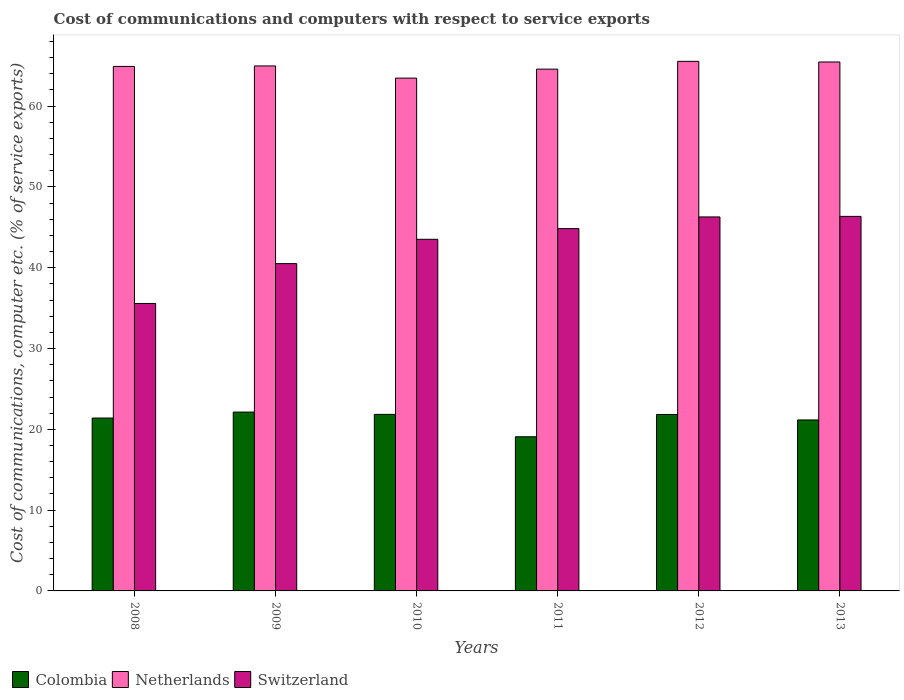How many different coloured bars are there?
Your answer should be very brief. 3. Are the number of bars per tick equal to the number of legend labels?
Your answer should be compact. Yes. Are the number of bars on each tick of the X-axis equal?
Provide a succinct answer. Yes. How many bars are there on the 1st tick from the left?
Your answer should be compact. 3. How many bars are there on the 5th tick from the right?
Keep it short and to the point. 3. What is the label of the 3rd group of bars from the left?
Your response must be concise. 2010. What is the cost of communications and computers in Colombia in 2008?
Ensure brevity in your answer.  21.4. Across all years, what is the maximum cost of communications and computers in Switzerland?
Give a very brief answer. 46.35. Across all years, what is the minimum cost of communications and computers in Switzerland?
Ensure brevity in your answer.  35.58. What is the total cost of communications and computers in Switzerland in the graph?
Your answer should be very brief. 257.08. What is the difference between the cost of communications and computers in Switzerland in 2008 and that in 2012?
Your answer should be very brief. -10.71. What is the difference between the cost of communications and computers in Switzerland in 2009 and the cost of communications and computers in Netherlands in 2013?
Your answer should be compact. -24.96. What is the average cost of communications and computers in Switzerland per year?
Your answer should be very brief. 42.85. In the year 2011, what is the difference between the cost of communications and computers in Switzerland and cost of communications and computers in Colombia?
Keep it short and to the point. 25.76. In how many years, is the cost of communications and computers in Netherlands greater than 54 %?
Provide a short and direct response. 6. What is the ratio of the cost of communications and computers in Netherlands in 2009 to that in 2013?
Make the answer very short. 0.99. What is the difference between the highest and the second highest cost of communications and computers in Switzerland?
Offer a terse response. 0.07. What is the difference between the highest and the lowest cost of communications and computers in Colombia?
Make the answer very short. 3.06. What does the 3rd bar from the left in 2012 represents?
Your answer should be very brief. Switzerland. Is it the case that in every year, the sum of the cost of communications and computers in Switzerland and cost of communications and computers in Colombia is greater than the cost of communications and computers in Netherlands?
Provide a succinct answer. No. Are all the bars in the graph horizontal?
Your answer should be compact. No. Are the values on the major ticks of Y-axis written in scientific E-notation?
Your answer should be very brief. No. Where does the legend appear in the graph?
Keep it short and to the point. Bottom left. How are the legend labels stacked?
Offer a very short reply. Horizontal. What is the title of the graph?
Provide a succinct answer. Cost of communications and computers with respect to service exports. What is the label or title of the Y-axis?
Your answer should be compact. Cost of communications, computer etc. (% of service exports). What is the Cost of communications, computer etc. (% of service exports) in Colombia in 2008?
Offer a very short reply. 21.4. What is the Cost of communications, computer etc. (% of service exports) of Netherlands in 2008?
Provide a succinct answer. 64.91. What is the Cost of communications, computer etc. (% of service exports) of Switzerland in 2008?
Offer a very short reply. 35.58. What is the Cost of communications, computer etc. (% of service exports) of Colombia in 2009?
Your answer should be very brief. 22.14. What is the Cost of communications, computer etc. (% of service exports) of Netherlands in 2009?
Offer a terse response. 64.97. What is the Cost of communications, computer etc. (% of service exports) in Switzerland in 2009?
Provide a succinct answer. 40.51. What is the Cost of communications, computer etc. (% of service exports) in Colombia in 2010?
Keep it short and to the point. 21.85. What is the Cost of communications, computer etc. (% of service exports) in Netherlands in 2010?
Your answer should be compact. 63.47. What is the Cost of communications, computer etc. (% of service exports) in Switzerland in 2010?
Your answer should be compact. 43.52. What is the Cost of communications, computer etc. (% of service exports) of Colombia in 2011?
Provide a short and direct response. 19.08. What is the Cost of communications, computer etc. (% of service exports) in Netherlands in 2011?
Keep it short and to the point. 64.58. What is the Cost of communications, computer etc. (% of service exports) in Switzerland in 2011?
Your answer should be very brief. 44.84. What is the Cost of communications, computer etc. (% of service exports) in Colombia in 2012?
Make the answer very short. 21.84. What is the Cost of communications, computer etc. (% of service exports) in Netherlands in 2012?
Ensure brevity in your answer.  65.54. What is the Cost of communications, computer etc. (% of service exports) of Switzerland in 2012?
Your answer should be very brief. 46.29. What is the Cost of communications, computer etc. (% of service exports) of Colombia in 2013?
Make the answer very short. 21.16. What is the Cost of communications, computer etc. (% of service exports) in Netherlands in 2013?
Keep it short and to the point. 65.46. What is the Cost of communications, computer etc. (% of service exports) of Switzerland in 2013?
Your answer should be compact. 46.35. Across all years, what is the maximum Cost of communications, computer etc. (% of service exports) of Colombia?
Offer a terse response. 22.14. Across all years, what is the maximum Cost of communications, computer etc. (% of service exports) of Netherlands?
Your answer should be compact. 65.54. Across all years, what is the maximum Cost of communications, computer etc. (% of service exports) in Switzerland?
Your response must be concise. 46.35. Across all years, what is the minimum Cost of communications, computer etc. (% of service exports) in Colombia?
Give a very brief answer. 19.08. Across all years, what is the minimum Cost of communications, computer etc. (% of service exports) in Netherlands?
Offer a terse response. 63.47. Across all years, what is the minimum Cost of communications, computer etc. (% of service exports) of Switzerland?
Ensure brevity in your answer.  35.58. What is the total Cost of communications, computer etc. (% of service exports) of Colombia in the graph?
Your answer should be compact. 127.46. What is the total Cost of communications, computer etc. (% of service exports) of Netherlands in the graph?
Offer a terse response. 388.93. What is the total Cost of communications, computer etc. (% of service exports) in Switzerland in the graph?
Your response must be concise. 257.08. What is the difference between the Cost of communications, computer etc. (% of service exports) in Colombia in 2008 and that in 2009?
Keep it short and to the point. -0.74. What is the difference between the Cost of communications, computer etc. (% of service exports) of Netherlands in 2008 and that in 2009?
Provide a succinct answer. -0.06. What is the difference between the Cost of communications, computer etc. (% of service exports) in Switzerland in 2008 and that in 2009?
Ensure brevity in your answer.  -4.93. What is the difference between the Cost of communications, computer etc. (% of service exports) in Colombia in 2008 and that in 2010?
Offer a terse response. -0.45. What is the difference between the Cost of communications, computer etc. (% of service exports) in Netherlands in 2008 and that in 2010?
Make the answer very short. 1.45. What is the difference between the Cost of communications, computer etc. (% of service exports) of Switzerland in 2008 and that in 2010?
Your response must be concise. -7.94. What is the difference between the Cost of communications, computer etc. (% of service exports) of Colombia in 2008 and that in 2011?
Give a very brief answer. 2.32. What is the difference between the Cost of communications, computer etc. (% of service exports) in Netherlands in 2008 and that in 2011?
Provide a succinct answer. 0.34. What is the difference between the Cost of communications, computer etc. (% of service exports) of Switzerland in 2008 and that in 2011?
Your response must be concise. -9.26. What is the difference between the Cost of communications, computer etc. (% of service exports) of Colombia in 2008 and that in 2012?
Your response must be concise. -0.44. What is the difference between the Cost of communications, computer etc. (% of service exports) in Netherlands in 2008 and that in 2012?
Offer a very short reply. -0.63. What is the difference between the Cost of communications, computer etc. (% of service exports) of Switzerland in 2008 and that in 2012?
Provide a succinct answer. -10.71. What is the difference between the Cost of communications, computer etc. (% of service exports) of Colombia in 2008 and that in 2013?
Ensure brevity in your answer.  0.24. What is the difference between the Cost of communications, computer etc. (% of service exports) of Netherlands in 2008 and that in 2013?
Provide a succinct answer. -0.55. What is the difference between the Cost of communications, computer etc. (% of service exports) in Switzerland in 2008 and that in 2013?
Make the answer very short. -10.78. What is the difference between the Cost of communications, computer etc. (% of service exports) of Colombia in 2009 and that in 2010?
Give a very brief answer. 0.29. What is the difference between the Cost of communications, computer etc. (% of service exports) of Netherlands in 2009 and that in 2010?
Your answer should be very brief. 1.51. What is the difference between the Cost of communications, computer etc. (% of service exports) in Switzerland in 2009 and that in 2010?
Your response must be concise. -3.01. What is the difference between the Cost of communications, computer etc. (% of service exports) of Colombia in 2009 and that in 2011?
Offer a terse response. 3.06. What is the difference between the Cost of communications, computer etc. (% of service exports) of Netherlands in 2009 and that in 2011?
Ensure brevity in your answer.  0.4. What is the difference between the Cost of communications, computer etc. (% of service exports) in Switzerland in 2009 and that in 2011?
Offer a very short reply. -4.33. What is the difference between the Cost of communications, computer etc. (% of service exports) of Colombia in 2009 and that in 2012?
Give a very brief answer. 0.3. What is the difference between the Cost of communications, computer etc. (% of service exports) of Netherlands in 2009 and that in 2012?
Offer a very short reply. -0.57. What is the difference between the Cost of communications, computer etc. (% of service exports) in Switzerland in 2009 and that in 2012?
Provide a short and direct response. -5.78. What is the difference between the Cost of communications, computer etc. (% of service exports) of Colombia in 2009 and that in 2013?
Make the answer very short. 0.98. What is the difference between the Cost of communications, computer etc. (% of service exports) of Netherlands in 2009 and that in 2013?
Offer a very short reply. -0.49. What is the difference between the Cost of communications, computer etc. (% of service exports) of Switzerland in 2009 and that in 2013?
Offer a very short reply. -5.85. What is the difference between the Cost of communications, computer etc. (% of service exports) in Colombia in 2010 and that in 2011?
Provide a short and direct response. 2.77. What is the difference between the Cost of communications, computer etc. (% of service exports) of Netherlands in 2010 and that in 2011?
Offer a very short reply. -1.11. What is the difference between the Cost of communications, computer etc. (% of service exports) in Switzerland in 2010 and that in 2011?
Provide a succinct answer. -1.32. What is the difference between the Cost of communications, computer etc. (% of service exports) in Colombia in 2010 and that in 2012?
Your answer should be compact. 0.01. What is the difference between the Cost of communications, computer etc. (% of service exports) of Netherlands in 2010 and that in 2012?
Make the answer very short. -2.07. What is the difference between the Cost of communications, computer etc. (% of service exports) in Switzerland in 2010 and that in 2012?
Your answer should be compact. -2.77. What is the difference between the Cost of communications, computer etc. (% of service exports) of Colombia in 2010 and that in 2013?
Your answer should be very brief. 0.69. What is the difference between the Cost of communications, computer etc. (% of service exports) in Netherlands in 2010 and that in 2013?
Ensure brevity in your answer.  -2. What is the difference between the Cost of communications, computer etc. (% of service exports) of Switzerland in 2010 and that in 2013?
Your answer should be very brief. -2.84. What is the difference between the Cost of communications, computer etc. (% of service exports) of Colombia in 2011 and that in 2012?
Ensure brevity in your answer.  -2.76. What is the difference between the Cost of communications, computer etc. (% of service exports) in Netherlands in 2011 and that in 2012?
Keep it short and to the point. -0.96. What is the difference between the Cost of communications, computer etc. (% of service exports) of Switzerland in 2011 and that in 2012?
Your answer should be compact. -1.45. What is the difference between the Cost of communications, computer etc. (% of service exports) of Colombia in 2011 and that in 2013?
Provide a succinct answer. -2.08. What is the difference between the Cost of communications, computer etc. (% of service exports) of Netherlands in 2011 and that in 2013?
Your answer should be very brief. -0.89. What is the difference between the Cost of communications, computer etc. (% of service exports) of Switzerland in 2011 and that in 2013?
Your answer should be very brief. -1.52. What is the difference between the Cost of communications, computer etc. (% of service exports) in Colombia in 2012 and that in 2013?
Give a very brief answer. 0.68. What is the difference between the Cost of communications, computer etc. (% of service exports) in Netherlands in 2012 and that in 2013?
Make the answer very short. 0.08. What is the difference between the Cost of communications, computer etc. (% of service exports) in Switzerland in 2012 and that in 2013?
Your response must be concise. -0.07. What is the difference between the Cost of communications, computer etc. (% of service exports) of Colombia in 2008 and the Cost of communications, computer etc. (% of service exports) of Netherlands in 2009?
Offer a terse response. -43.58. What is the difference between the Cost of communications, computer etc. (% of service exports) in Colombia in 2008 and the Cost of communications, computer etc. (% of service exports) in Switzerland in 2009?
Your response must be concise. -19.11. What is the difference between the Cost of communications, computer etc. (% of service exports) of Netherlands in 2008 and the Cost of communications, computer etc. (% of service exports) of Switzerland in 2009?
Make the answer very short. 24.4. What is the difference between the Cost of communications, computer etc. (% of service exports) of Colombia in 2008 and the Cost of communications, computer etc. (% of service exports) of Netherlands in 2010?
Provide a short and direct response. -42.07. What is the difference between the Cost of communications, computer etc. (% of service exports) of Colombia in 2008 and the Cost of communications, computer etc. (% of service exports) of Switzerland in 2010?
Offer a very short reply. -22.12. What is the difference between the Cost of communications, computer etc. (% of service exports) of Netherlands in 2008 and the Cost of communications, computer etc. (% of service exports) of Switzerland in 2010?
Offer a very short reply. 21.39. What is the difference between the Cost of communications, computer etc. (% of service exports) of Colombia in 2008 and the Cost of communications, computer etc. (% of service exports) of Netherlands in 2011?
Ensure brevity in your answer.  -43.18. What is the difference between the Cost of communications, computer etc. (% of service exports) in Colombia in 2008 and the Cost of communications, computer etc. (% of service exports) in Switzerland in 2011?
Your answer should be compact. -23.44. What is the difference between the Cost of communications, computer etc. (% of service exports) of Netherlands in 2008 and the Cost of communications, computer etc. (% of service exports) of Switzerland in 2011?
Make the answer very short. 20.07. What is the difference between the Cost of communications, computer etc. (% of service exports) of Colombia in 2008 and the Cost of communications, computer etc. (% of service exports) of Netherlands in 2012?
Keep it short and to the point. -44.15. What is the difference between the Cost of communications, computer etc. (% of service exports) in Colombia in 2008 and the Cost of communications, computer etc. (% of service exports) in Switzerland in 2012?
Offer a very short reply. -24.89. What is the difference between the Cost of communications, computer etc. (% of service exports) in Netherlands in 2008 and the Cost of communications, computer etc. (% of service exports) in Switzerland in 2012?
Provide a succinct answer. 18.63. What is the difference between the Cost of communications, computer etc. (% of service exports) in Colombia in 2008 and the Cost of communications, computer etc. (% of service exports) in Netherlands in 2013?
Ensure brevity in your answer.  -44.07. What is the difference between the Cost of communications, computer etc. (% of service exports) in Colombia in 2008 and the Cost of communications, computer etc. (% of service exports) in Switzerland in 2013?
Ensure brevity in your answer.  -24.96. What is the difference between the Cost of communications, computer etc. (% of service exports) of Netherlands in 2008 and the Cost of communications, computer etc. (% of service exports) of Switzerland in 2013?
Provide a succinct answer. 18.56. What is the difference between the Cost of communications, computer etc. (% of service exports) in Colombia in 2009 and the Cost of communications, computer etc. (% of service exports) in Netherlands in 2010?
Your response must be concise. -41.33. What is the difference between the Cost of communications, computer etc. (% of service exports) of Colombia in 2009 and the Cost of communications, computer etc. (% of service exports) of Switzerland in 2010?
Ensure brevity in your answer.  -21.38. What is the difference between the Cost of communications, computer etc. (% of service exports) of Netherlands in 2009 and the Cost of communications, computer etc. (% of service exports) of Switzerland in 2010?
Ensure brevity in your answer.  21.45. What is the difference between the Cost of communications, computer etc. (% of service exports) in Colombia in 2009 and the Cost of communications, computer etc. (% of service exports) in Netherlands in 2011?
Your response must be concise. -42.44. What is the difference between the Cost of communications, computer etc. (% of service exports) in Colombia in 2009 and the Cost of communications, computer etc. (% of service exports) in Switzerland in 2011?
Offer a terse response. -22.7. What is the difference between the Cost of communications, computer etc. (% of service exports) in Netherlands in 2009 and the Cost of communications, computer etc. (% of service exports) in Switzerland in 2011?
Offer a very short reply. 20.13. What is the difference between the Cost of communications, computer etc. (% of service exports) in Colombia in 2009 and the Cost of communications, computer etc. (% of service exports) in Netherlands in 2012?
Ensure brevity in your answer.  -43.4. What is the difference between the Cost of communications, computer etc. (% of service exports) of Colombia in 2009 and the Cost of communications, computer etc. (% of service exports) of Switzerland in 2012?
Ensure brevity in your answer.  -24.15. What is the difference between the Cost of communications, computer etc. (% of service exports) in Netherlands in 2009 and the Cost of communications, computer etc. (% of service exports) in Switzerland in 2012?
Provide a short and direct response. 18.69. What is the difference between the Cost of communications, computer etc. (% of service exports) of Colombia in 2009 and the Cost of communications, computer etc. (% of service exports) of Netherlands in 2013?
Your answer should be compact. -43.33. What is the difference between the Cost of communications, computer etc. (% of service exports) in Colombia in 2009 and the Cost of communications, computer etc. (% of service exports) in Switzerland in 2013?
Your response must be concise. -24.22. What is the difference between the Cost of communications, computer etc. (% of service exports) in Netherlands in 2009 and the Cost of communications, computer etc. (% of service exports) in Switzerland in 2013?
Ensure brevity in your answer.  18.62. What is the difference between the Cost of communications, computer etc. (% of service exports) of Colombia in 2010 and the Cost of communications, computer etc. (% of service exports) of Netherlands in 2011?
Offer a terse response. -42.73. What is the difference between the Cost of communications, computer etc. (% of service exports) of Colombia in 2010 and the Cost of communications, computer etc. (% of service exports) of Switzerland in 2011?
Provide a short and direct response. -22.99. What is the difference between the Cost of communications, computer etc. (% of service exports) of Netherlands in 2010 and the Cost of communications, computer etc. (% of service exports) of Switzerland in 2011?
Make the answer very short. 18.63. What is the difference between the Cost of communications, computer etc. (% of service exports) in Colombia in 2010 and the Cost of communications, computer etc. (% of service exports) in Netherlands in 2012?
Provide a short and direct response. -43.69. What is the difference between the Cost of communications, computer etc. (% of service exports) of Colombia in 2010 and the Cost of communications, computer etc. (% of service exports) of Switzerland in 2012?
Ensure brevity in your answer.  -24.44. What is the difference between the Cost of communications, computer etc. (% of service exports) of Netherlands in 2010 and the Cost of communications, computer etc. (% of service exports) of Switzerland in 2012?
Your answer should be very brief. 17.18. What is the difference between the Cost of communications, computer etc. (% of service exports) in Colombia in 2010 and the Cost of communications, computer etc. (% of service exports) in Netherlands in 2013?
Give a very brief answer. -43.62. What is the difference between the Cost of communications, computer etc. (% of service exports) of Colombia in 2010 and the Cost of communications, computer etc. (% of service exports) of Switzerland in 2013?
Offer a very short reply. -24.51. What is the difference between the Cost of communications, computer etc. (% of service exports) of Netherlands in 2010 and the Cost of communications, computer etc. (% of service exports) of Switzerland in 2013?
Ensure brevity in your answer.  17.11. What is the difference between the Cost of communications, computer etc. (% of service exports) of Colombia in 2011 and the Cost of communications, computer etc. (% of service exports) of Netherlands in 2012?
Provide a short and direct response. -46.46. What is the difference between the Cost of communications, computer etc. (% of service exports) in Colombia in 2011 and the Cost of communications, computer etc. (% of service exports) in Switzerland in 2012?
Make the answer very short. -27.21. What is the difference between the Cost of communications, computer etc. (% of service exports) of Netherlands in 2011 and the Cost of communications, computer etc. (% of service exports) of Switzerland in 2012?
Make the answer very short. 18.29. What is the difference between the Cost of communications, computer etc. (% of service exports) in Colombia in 2011 and the Cost of communications, computer etc. (% of service exports) in Netherlands in 2013?
Provide a succinct answer. -46.38. What is the difference between the Cost of communications, computer etc. (% of service exports) in Colombia in 2011 and the Cost of communications, computer etc. (% of service exports) in Switzerland in 2013?
Your answer should be compact. -27.27. What is the difference between the Cost of communications, computer etc. (% of service exports) in Netherlands in 2011 and the Cost of communications, computer etc. (% of service exports) in Switzerland in 2013?
Your answer should be compact. 18.22. What is the difference between the Cost of communications, computer etc. (% of service exports) of Colombia in 2012 and the Cost of communications, computer etc. (% of service exports) of Netherlands in 2013?
Your response must be concise. -43.62. What is the difference between the Cost of communications, computer etc. (% of service exports) of Colombia in 2012 and the Cost of communications, computer etc. (% of service exports) of Switzerland in 2013?
Your answer should be compact. -24.52. What is the difference between the Cost of communications, computer etc. (% of service exports) of Netherlands in 2012 and the Cost of communications, computer etc. (% of service exports) of Switzerland in 2013?
Provide a succinct answer. 19.19. What is the average Cost of communications, computer etc. (% of service exports) of Colombia per year?
Provide a short and direct response. 21.24. What is the average Cost of communications, computer etc. (% of service exports) of Netherlands per year?
Make the answer very short. 64.82. What is the average Cost of communications, computer etc. (% of service exports) in Switzerland per year?
Keep it short and to the point. 42.85. In the year 2008, what is the difference between the Cost of communications, computer etc. (% of service exports) of Colombia and Cost of communications, computer etc. (% of service exports) of Netherlands?
Your answer should be compact. -43.52. In the year 2008, what is the difference between the Cost of communications, computer etc. (% of service exports) in Colombia and Cost of communications, computer etc. (% of service exports) in Switzerland?
Offer a very short reply. -14.18. In the year 2008, what is the difference between the Cost of communications, computer etc. (% of service exports) in Netherlands and Cost of communications, computer etc. (% of service exports) in Switzerland?
Your answer should be compact. 29.34. In the year 2009, what is the difference between the Cost of communications, computer etc. (% of service exports) in Colombia and Cost of communications, computer etc. (% of service exports) in Netherlands?
Offer a very short reply. -42.84. In the year 2009, what is the difference between the Cost of communications, computer etc. (% of service exports) of Colombia and Cost of communications, computer etc. (% of service exports) of Switzerland?
Make the answer very short. -18.37. In the year 2009, what is the difference between the Cost of communications, computer etc. (% of service exports) of Netherlands and Cost of communications, computer etc. (% of service exports) of Switzerland?
Provide a succinct answer. 24.47. In the year 2010, what is the difference between the Cost of communications, computer etc. (% of service exports) in Colombia and Cost of communications, computer etc. (% of service exports) in Netherlands?
Offer a very short reply. -41.62. In the year 2010, what is the difference between the Cost of communications, computer etc. (% of service exports) of Colombia and Cost of communications, computer etc. (% of service exports) of Switzerland?
Ensure brevity in your answer.  -21.67. In the year 2010, what is the difference between the Cost of communications, computer etc. (% of service exports) of Netherlands and Cost of communications, computer etc. (% of service exports) of Switzerland?
Provide a succinct answer. 19.95. In the year 2011, what is the difference between the Cost of communications, computer etc. (% of service exports) of Colombia and Cost of communications, computer etc. (% of service exports) of Netherlands?
Provide a short and direct response. -45.5. In the year 2011, what is the difference between the Cost of communications, computer etc. (% of service exports) in Colombia and Cost of communications, computer etc. (% of service exports) in Switzerland?
Your answer should be compact. -25.76. In the year 2011, what is the difference between the Cost of communications, computer etc. (% of service exports) of Netherlands and Cost of communications, computer etc. (% of service exports) of Switzerland?
Your answer should be compact. 19.74. In the year 2012, what is the difference between the Cost of communications, computer etc. (% of service exports) in Colombia and Cost of communications, computer etc. (% of service exports) in Netherlands?
Offer a terse response. -43.7. In the year 2012, what is the difference between the Cost of communications, computer etc. (% of service exports) of Colombia and Cost of communications, computer etc. (% of service exports) of Switzerland?
Provide a succinct answer. -24.45. In the year 2012, what is the difference between the Cost of communications, computer etc. (% of service exports) of Netherlands and Cost of communications, computer etc. (% of service exports) of Switzerland?
Offer a very short reply. 19.26. In the year 2013, what is the difference between the Cost of communications, computer etc. (% of service exports) in Colombia and Cost of communications, computer etc. (% of service exports) in Netherlands?
Offer a terse response. -44.3. In the year 2013, what is the difference between the Cost of communications, computer etc. (% of service exports) of Colombia and Cost of communications, computer etc. (% of service exports) of Switzerland?
Make the answer very short. -25.2. In the year 2013, what is the difference between the Cost of communications, computer etc. (% of service exports) of Netherlands and Cost of communications, computer etc. (% of service exports) of Switzerland?
Offer a very short reply. 19.11. What is the ratio of the Cost of communications, computer etc. (% of service exports) in Colombia in 2008 to that in 2009?
Make the answer very short. 0.97. What is the ratio of the Cost of communications, computer etc. (% of service exports) of Switzerland in 2008 to that in 2009?
Offer a terse response. 0.88. What is the ratio of the Cost of communications, computer etc. (% of service exports) in Colombia in 2008 to that in 2010?
Offer a very short reply. 0.98. What is the ratio of the Cost of communications, computer etc. (% of service exports) of Netherlands in 2008 to that in 2010?
Provide a short and direct response. 1.02. What is the ratio of the Cost of communications, computer etc. (% of service exports) of Switzerland in 2008 to that in 2010?
Keep it short and to the point. 0.82. What is the ratio of the Cost of communications, computer etc. (% of service exports) of Colombia in 2008 to that in 2011?
Offer a very short reply. 1.12. What is the ratio of the Cost of communications, computer etc. (% of service exports) of Switzerland in 2008 to that in 2011?
Offer a very short reply. 0.79. What is the ratio of the Cost of communications, computer etc. (% of service exports) in Colombia in 2008 to that in 2012?
Give a very brief answer. 0.98. What is the ratio of the Cost of communications, computer etc. (% of service exports) of Netherlands in 2008 to that in 2012?
Your answer should be very brief. 0.99. What is the ratio of the Cost of communications, computer etc. (% of service exports) of Switzerland in 2008 to that in 2012?
Ensure brevity in your answer.  0.77. What is the ratio of the Cost of communications, computer etc. (% of service exports) of Colombia in 2008 to that in 2013?
Offer a very short reply. 1.01. What is the ratio of the Cost of communications, computer etc. (% of service exports) in Switzerland in 2008 to that in 2013?
Make the answer very short. 0.77. What is the ratio of the Cost of communications, computer etc. (% of service exports) of Colombia in 2009 to that in 2010?
Provide a short and direct response. 1.01. What is the ratio of the Cost of communications, computer etc. (% of service exports) of Netherlands in 2009 to that in 2010?
Make the answer very short. 1.02. What is the ratio of the Cost of communications, computer etc. (% of service exports) of Switzerland in 2009 to that in 2010?
Keep it short and to the point. 0.93. What is the ratio of the Cost of communications, computer etc. (% of service exports) in Colombia in 2009 to that in 2011?
Provide a succinct answer. 1.16. What is the ratio of the Cost of communications, computer etc. (% of service exports) in Switzerland in 2009 to that in 2011?
Your answer should be compact. 0.9. What is the ratio of the Cost of communications, computer etc. (% of service exports) of Colombia in 2009 to that in 2012?
Provide a succinct answer. 1.01. What is the ratio of the Cost of communications, computer etc. (% of service exports) in Switzerland in 2009 to that in 2012?
Provide a short and direct response. 0.88. What is the ratio of the Cost of communications, computer etc. (% of service exports) of Colombia in 2009 to that in 2013?
Offer a very short reply. 1.05. What is the ratio of the Cost of communications, computer etc. (% of service exports) in Switzerland in 2009 to that in 2013?
Provide a short and direct response. 0.87. What is the ratio of the Cost of communications, computer etc. (% of service exports) in Colombia in 2010 to that in 2011?
Provide a succinct answer. 1.15. What is the ratio of the Cost of communications, computer etc. (% of service exports) of Netherlands in 2010 to that in 2011?
Give a very brief answer. 0.98. What is the ratio of the Cost of communications, computer etc. (% of service exports) of Switzerland in 2010 to that in 2011?
Keep it short and to the point. 0.97. What is the ratio of the Cost of communications, computer etc. (% of service exports) of Colombia in 2010 to that in 2012?
Offer a terse response. 1. What is the ratio of the Cost of communications, computer etc. (% of service exports) of Netherlands in 2010 to that in 2012?
Ensure brevity in your answer.  0.97. What is the ratio of the Cost of communications, computer etc. (% of service exports) of Switzerland in 2010 to that in 2012?
Provide a succinct answer. 0.94. What is the ratio of the Cost of communications, computer etc. (% of service exports) of Colombia in 2010 to that in 2013?
Give a very brief answer. 1.03. What is the ratio of the Cost of communications, computer etc. (% of service exports) in Netherlands in 2010 to that in 2013?
Ensure brevity in your answer.  0.97. What is the ratio of the Cost of communications, computer etc. (% of service exports) in Switzerland in 2010 to that in 2013?
Your answer should be compact. 0.94. What is the ratio of the Cost of communications, computer etc. (% of service exports) in Colombia in 2011 to that in 2012?
Your response must be concise. 0.87. What is the ratio of the Cost of communications, computer etc. (% of service exports) of Netherlands in 2011 to that in 2012?
Ensure brevity in your answer.  0.99. What is the ratio of the Cost of communications, computer etc. (% of service exports) in Switzerland in 2011 to that in 2012?
Offer a very short reply. 0.97. What is the ratio of the Cost of communications, computer etc. (% of service exports) of Colombia in 2011 to that in 2013?
Ensure brevity in your answer.  0.9. What is the ratio of the Cost of communications, computer etc. (% of service exports) of Netherlands in 2011 to that in 2013?
Provide a short and direct response. 0.99. What is the ratio of the Cost of communications, computer etc. (% of service exports) of Switzerland in 2011 to that in 2013?
Provide a short and direct response. 0.97. What is the ratio of the Cost of communications, computer etc. (% of service exports) of Colombia in 2012 to that in 2013?
Ensure brevity in your answer.  1.03. What is the ratio of the Cost of communications, computer etc. (% of service exports) of Netherlands in 2012 to that in 2013?
Keep it short and to the point. 1. What is the ratio of the Cost of communications, computer etc. (% of service exports) of Switzerland in 2012 to that in 2013?
Ensure brevity in your answer.  1. What is the difference between the highest and the second highest Cost of communications, computer etc. (% of service exports) in Colombia?
Provide a short and direct response. 0.29. What is the difference between the highest and the second highest Cost of communications, computer etc. (% of service exports) of Netherlands?
Your answer should be very brief. 0.08. What is the difference between the highest and the second highest Cost of communications, computer etc. (% of service exports) in Switzerland?
Give a very brief answer. 0.07. What is the difference between the highest and the lowest Cost of communications, computer etc. (% of service exports) of Colombia?
Ensure brevity in your answer.  3.06. What is the difference between the highest and the lowest Cost of communications, computer etc. (% of service exports) of Netherlands?
Offer a very short reply. 2.07. What is the difference between the highest and the lowest Cost of communications, computer etc. (% of service exports) of Switzerland?
Provide a succinct answer. 10.78. 